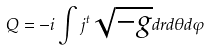<formula> <loc_0><loc_0><loc_500><loc_500>Q = - i \int j ^ { t } \sqrt { - g } d r d \theta d \varphi</formula> 